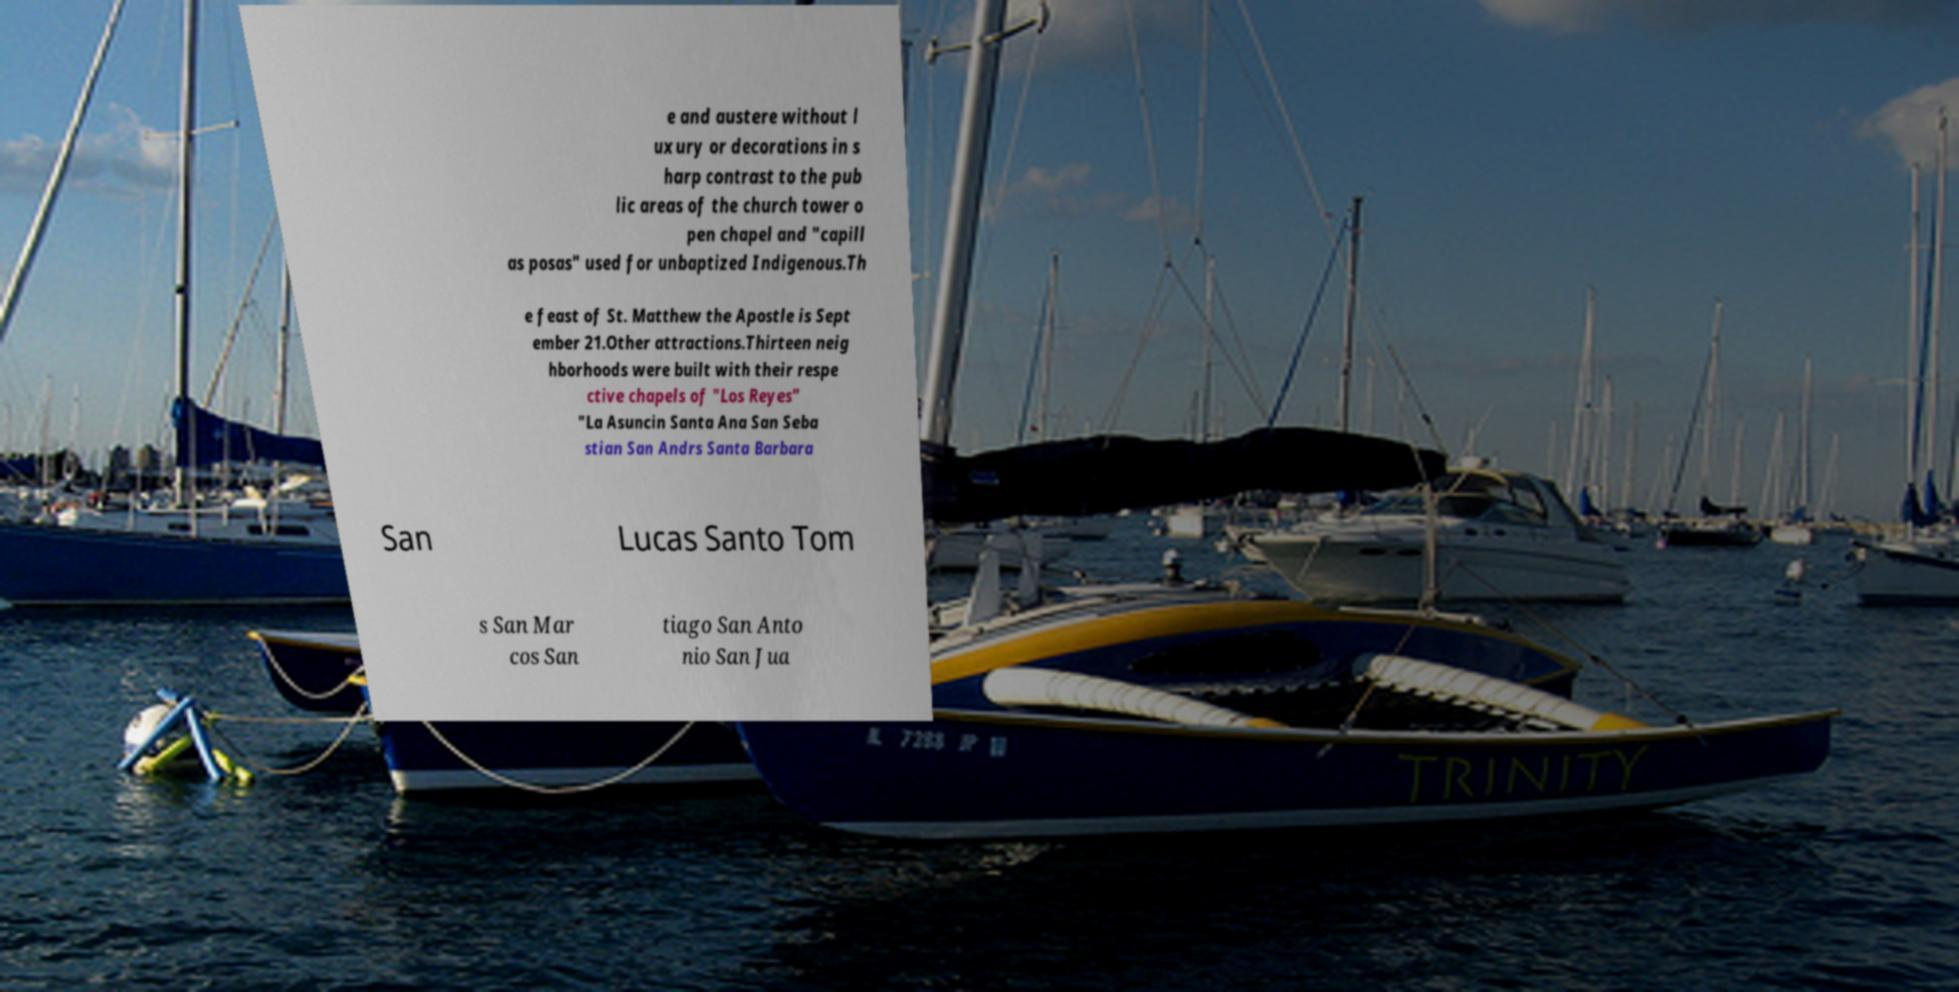Could you assist in decoding the text presented in this image and type it out clearly? e and austere without l uxury or decorations in s harp contrast to the pub lic areas of the church tower o pen chapel and "capill as posas" used for unbaptized Indigenous.Th e feast of St. Matthew the Apostle is Sept ember 21.Other attractions.Thirteen neig hborhoods were built with their respe ctive chapels of "Los Reyes" "La Asuncin Santa Ana San Seba stian San Andrs Santa Barbara San Lucas Santo Tom s San Mar cos San tiago San Anto nio San Jua 